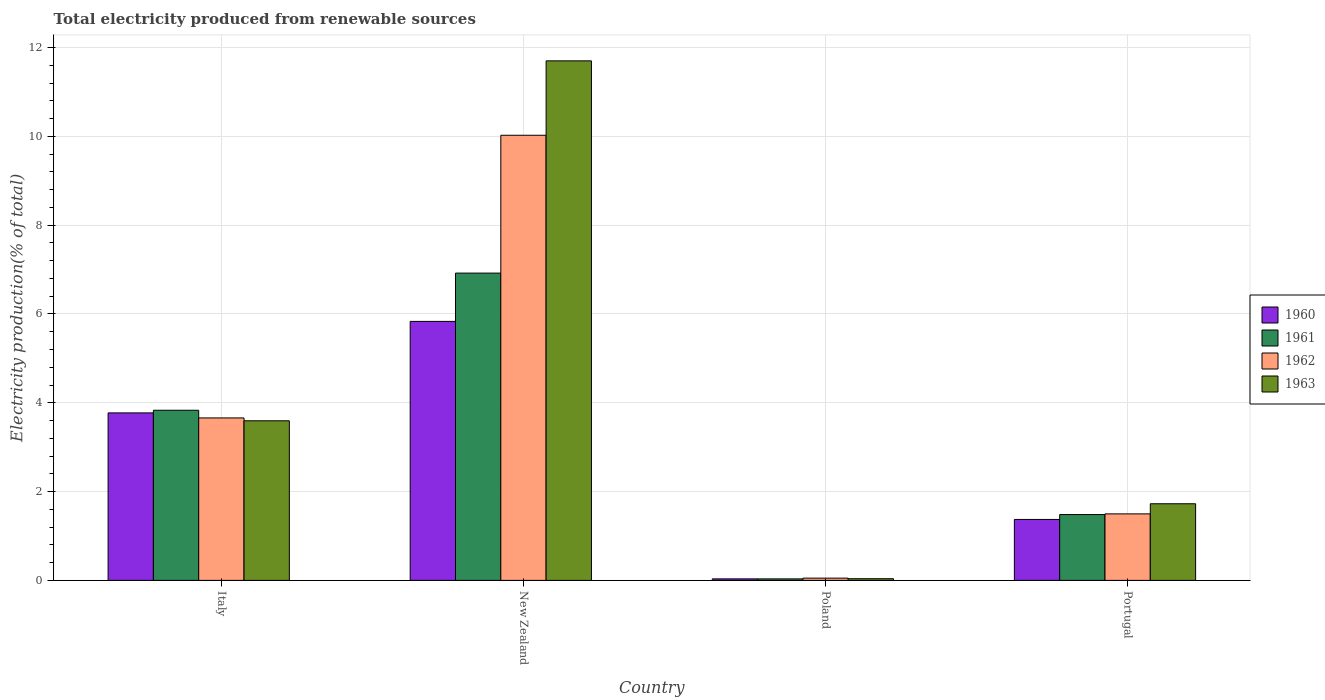Are the number of bars on each tick of the X-axis equal?
Your answer should be compact. Yes. What is the label of the 1st group of bars from the left?
Provide a short and direct response. Italy. What is the total electricity produced in 1963 in Italy?
Give a very brief answer. 3.59. Across all countries, what is the maximum total electricity produced in 1961?
Keep it short and to the point. 6.92. Across all countries, what is the minimum total electricity produced in 1960?
Ensure brevity in your answer.  0.03. In which country was the total electricity produced in 1962 maximum?
Offer a very short reply. New Zealand. In which country was the total electricity produced in 1960 minimum?
Provide a succinct answer. Poland. What is the total total electricity produced in 1963 in the graph?
Offer a terse response. 17.06. What is the difference between the total electricity produced in 1960 in Italy and that in New Zealand?
Your answer should be compact. -2.06. What is the difference between the total electricity produced in 1962 in Poland and the total electricity produced in 1961 in Portugal?
Your answer should be compact. -1.43. What is the average total electricity produced in 1963 per country?
Offer a terse response. 4.26. What is the difference between the total electricity produced of/in 1960 and total electricity produced of/in 1963 in Portugal?
Make the answer very short. -0.35. What is the ratio of the total electricity produced in 1960 in Italy to that in Portugal?
Your response must be concise. 2.75. Is the difference between the total electricity produced in 1960 in Italy and Portugal greater than the difference between the total electricity produced in 1963 in Italy and Portugal?
Make the answer very short. Yes. What is the difference between the highest and the second highest total electricity produced in 1960?
Make the answer very short. -2.4. What is the difference between the highest and the lowest total electricity produced in 1960?
Your response must be concise. 5.8. Is the sum of the total electricity produced in 1961 in Poland and Portugal greater than the maximum total electricity produced in 1960 across all countries?
Your response must be concise. No. What does the 4th bar from the right in New Zealand represents?
Keep it short and to the point. 1960. How many bars are there?
Make the answer very short. 16. Are all the bars in the graph horizontal?
Provide a succinct answer. No. What is the difference between two consecutive major ticks on the Y-axis?
Make the answer very short. 2. Are the values on the major ticks of Y-axis written in scientific E-notation?
Your response must be concise. No. Does the graph contain grids?
Provide a succinct answer. Yes. Where does the legend appear in the graph?
Provide a short and direct response. Center right. How are the legend labels stacked?
Make the answer very short. Vertical. What is the title of the graph?
Your response must be concise. Total electricity produced from renewable sources. What is the label or title of the X-axis?
Your response must be concise. Country. What is the Electricity production(% of total) in 1960 in Italy?
Make the answer very short. 3.77. What is the Electricity production(% of total) in 1961 in Italy?
Your response must be concise. 3.83. What is the Electricity production(% of total) of 1962 in Italy?
Your response must be concise. 3.66. What is the Electricity production(% of total) in 1963 in Italy?
Keep it short and to the point. 3.59. What is the Electricity production(% of total) of 1960 in New Zealand?
Offer a very short reply. 5.83. What is the Electricity production(% of total) in 1961 in New Zealand?
Give a very brief answer. 6.92. What is the Electricity production(% of total) in 1962 in New Zealand?
Provide a succinct answer. 10.02. What is the Electricity production(% of total) in 1963 in New Zealand?
Your answer should be very brief. 11.7. What is the Electricity production(% of total) in 1960 in Poland?
Keep it short and to the point. 0.03. What is the Electricity production(% of total) in 1961 in Poland?
Make the answer very short. 0.03. What is the Electricity production(% of total) in 1962 in Poland?
Your response must be concise. 0.05. What is the Electricity production(% of total) in 1963 in Poland?
Make the answer very short. 0.04. What is the Electricity production(% of total) of 1960 in Portugal?
Offer a terse response. 1.37. What is the Electricity production(% of total) of 1961 in Portugal?
Provide a succinct answer. 1.48. What is the Electricity production(% of total) in 1962 in Portugal?
Your response must be concise. 1.5. What is the Electricity production(% of total) in 1963 in Portugal?
Provide a succinct answer. 1.73. Across all countries, what is the maximum Electricity production(% of total) in 1960?
Ensure brevity in your answer.  5.83. Across all countries, what is the maximum Electricity production(% of total) of 1961?
Offer a very short reply. 6.92. Across all countries, what is the maximum Electricity production(% of total) of 1962?
Ensure brevity in your answer.  10.02. Across all countries, what is the maximum Electricity production(% of total) in 1963?
Offer a very short reply. 11.7. Across all countries, what is the minimum Electricity production(% of total) of 1960?
Provide a succinct answer. 0.03. Across all countries, what is the minimum Electricity production(% of total) in 1961?
Keep it short and to the point. 0.03. Across all countries, what is the minimum Electricity production(% of total) in 1962?
Offer a terse response. 0.05. Across all countries, what is the minimum Electricity production(% of total) in 1963?
Your answer should be very brief. 0.04. What is the total Electricity production(% of total) of 1960 in the graph?
Offer a very short reply. 11.01. What is the total Electricity production(% of total) in 1961 in the graph?
Ensure brevity in your answer.  12.27. What is the total Electricity production(% of total) in 1962 in the graph?
Your answer should be compact. 15.23. What is the total Electricity production(% of total) of 1963 in the graph?
Keep it short and to the point. 17.06. What is the difference between the Electricity production(% of total) of 1960 in Italy and that in New Zealand?
Provide a short and direct response. -2.06. What is the difference between the Electricity production(% of total) of 1961 in Italy and that in New Zealand?
Your response must be concise. -3.09. What is the difference between the Electricity production(% of total) in 1962 in Italy and that in New Zealand?
Give a very brief answer. -6.37. What is the difference between the Electricity production(% of total) of 1963 in Italy and that in New Zealand?
Your answer should be very brief. -8.11. What is the difference between the Electricity production(% of total) in 1960 in Italy and that in Poland?
Provide a short and direct response. 3.74. What is the difference between the Electricity production(% of total) of 1961 in Italy and that in Poland?
Offer a terse response. 3.8. What is the difference between the Electricity production(% of total) of 1962 in Italy and that in Poland?
Give a very brief answer. 3.61. What is the difference between the Electricity production(% of total) of 1963 in Italy and that in Poland?
Your response must be concise. 3.56. What is the difference between the Electricity production(% of total) in 1960 in Italy and that in Portugal?
Ensure brevity in your answer.  2.4. What is the difference between the Electricity production(% of total) in 1961 in Italy and that in Portugal?
Make the answer very short. 2.35. What is the difference between the Electricity production(% of total) of 1962 in Italy and that in Portugal?
Your response must be concise. 2.16. What is the difference between the Electricity production(% of total) in 1963 in Italy and that in Portugal?
Provide a short and direct response. 1.87. What is the difference between the Electricity production(% of total) of 1960 in New Zealand and that in Poland?
Provide a succinct answer. 5.8. What is the difference between the Electricity production(% of total) in 1961 in New Zealand and that in Poland?
Ensure brevity in your answer.  6.89. What is the difference between the Electricity production(% of total) of 1962 in New Zealand and that in Poland?
Your answer should be compact. 9.97. What is the difference between the Electricity production(% of total) in 1963 in New Zealand and that in Poland?
Provide a short and direct response. 11.66. What is the difference between the Electricity production(% of total) in 1960 in New Zealand and that in Portugal?
Provide a succinct answer. 4.46. What is the difference between the Electricity production(% of total) of 1961 in New Zealand and that in Portugal?
Your response must be concise. 5.44. What is the difference between the Electricity production(% of total) in 1962 in New Zealand and that in Portugal?
Offer a very short reply. 8.53. What is the difference between the Electricity production(% of total) in 1963 in New Zealand and that in Portugal?
Your answer should be compact. 9.97. What is the difference between the Electricity production(% of total) of 1960 in Poland and that in Portugal?
Your answer should be compact. -1.34. What is the difference between the Electricity production(% of total) in 1961 in Poland and that in Portugal?
Provide a short and direct response. -1.45. What is the difference between the Electricity production(% of total) of 1962 in Poland and that in Portugal?
Offer a terse response. -1.45. What is the difference between the Electricity production(% of total) in 1963 in Poland and that in Portugal?
Give a very brief answer. -1.69. What is the difference between the Electricity production(% of total) of 1960 in Italy and the Electricity production(% of total) of 1961 in New Zealand?
Offer a terse response. -3.15. What is the difference between the Electricity production(% of total) of 1960 in Italy and the Electricity production(% of total) of 1962 in New Zealand?
Offer a terse response. -6.25. What is the difference between the Electricity production(% of total) of 1960 in Italy and the Electricity production(% of total) of 1963 in New Zealand?
Make the answer very short. -7.93. What is the difference between the Electricity production(% of total) in 1961 in Italy and the Electricity production(% of total) in 1962 in New Zealand?
Keep it short and to the point. -6.19. What is the difference between the Electricity production(% of total) in 1961 in Italy and the Electricity production(% of total) in 1963 in New Zealand?
Give a very brief answer. -7.87. What is the difference between the Electricity production(% of total) in 1962 in Italy and the Electricity production(% of total) in 1963 in New Zealand?
Your answer should be compact. -8.04. What is the difference between the Electricity production(% of total) of 1960 in Italy and the Electricity production(% of total) of 1961 in Poland?
Provide a short and direct response. 3.74. What is the difference between the Electricity production(% of total) of 1960 in Italy and the Electricity production(% of total) of 1962 in Poland?
Give a very brief answer. 3.72. What is the difference between the Electricity production(% of total) in 1960 in Italy and the Electricity production(% of total) in 1963 in Poland?
Give a very brief answer. 3.73. What is the difference between the Electricity production(% of total) in 1961 in Italy and the Electricity production(% of total) in 1962 in Poland?
Give a very brief answer. 3.78. What is the difference between the Electricity production(% of total) in 1961 in Italy and the Electricity production(% of total) in 1963 in Poland?
Your answer should be compact. 3.79. What is the difference between the Electricity production(% of total) of 1962 in Italy and the Electricity production(% of total) of 1963 in Poland?
Give a very brief answer. 3.62. What is the difference between the Electricity production(% of total) in 1960 in Italy and the Electricity production(% of total) in 1961 in Portugal?
Keep it short and to the point. 2.29. What is the difference between the Electricity production(% of total) in 1960 in Italy and the Electricity production(% of total) in 1962 in Portugal?
Ensure brevity in your answer.  2.27. What is the difference between the Electricity production(% of total) in 1960 in Italy and the Electricity production(% of total) in 1963 in Portugal?
Give a very brief answer. 2.05. What is the difference between the Electricity production(% of total) of 1961 in Italy and the Electricity production(% of total) of 1962 in Portugal?
Keep it short and to the point. 2.33. What is the difference between the Electricity production(% of total) in 1961 in Italy and the Electricity production(% of total) in 1963 in Portugal?
Your answer should be compact. 2.11. What is the difference between the Electricity production(% of total) of 1962 in Italy and the Electricity production(% of total) of 1963 in Portugal?
Make the answer very short. 1.93. What is the difference between the Electricity production(% of total) of 1960 in New Zealand and the Electricity production(% of total) of 1961 in Poland?
Provide a short and direct response. 5.8. What is the difference between the Electricity production(% of total) in 1960 in New Zealand and the Electricity production(% of total) in 1962 in Poland?
Provide a succinct answer. 5.78. What is the difference between the Electricity production(% of total) in 1960 in New Zealand and the Electricity production(% of total) in 1963 in Poland?
Provide a short and direct response. 5.79. What is the difference between the Electricity production(% of total) of 1961 in New Zealand and the Electricity production(% of total) of 1962 in Poland?
Provide a short and direct response. 6.87. What is the difference between the Electricity production(% of total) of 1961 in New Zealand and the Electricity production(% of total) of 1963 in Poland?
Provide a succinct answer. 6.88. What is the difference between the Electricity production(% of total) in 1962 in New Zealand and the Electricity production(% of total) in 1963 in Poland?
Offer a terse response. 9.99. What is the difference between the Electricity production(% of total) in 1960 in New Zealand and the Electricity production(% of total) in 1961 in Portugal?
Offer a terse response. 4.35. What is the difference between the Electricity production(% of total) in 1960 in New Zealand and the Electricity production(% of total) in 1962 in Portugal?
Make the answer very short. 4.33. What is the difference between the Electricity production(% of total) in 1960 in New Zealand and the Electricity production(% of total) in 1963 in Portugal?
Offer a terse response. 4.11. What is the difference between the Electricity production(% of total) of 1961 in New Zealand and the Electricity production(% of total) of 1962 in Portugal?
Provide a short and direct response. 5.42. What is the difference between the Electricity production(% of total) in 1961 in New Zealand and the Electricity production(% of total) in 1963 in Portugal?
Your answer should be compact. 5.19. What is the difference between the Electricity production(% of total) in 1962 in New Zealand and the Electricity production(% of total) in 1963 in Portugal?
Offer a terse response. 8.3. What is the difference between the Electricity production(% of total) of 1960 in Poland and the Electricity production(% of total) of 1961 in Portugal?
Offer a very short reply. -1.45. What is the difference between the Electricity production(% of total) in 1960 in Poland and the Electricity production(% of total) in 1962 in Portugal?
Provide a succinct answer. -1.46. What is the difference between the Electricity production(% of total) of 1960 in Poland and the Electricity production(% of total) of 1963 in Portugal?
Provide a short and direct response. -1.69. What is the difference between the Electricity production(% of total) in 1961 in Poland and the Electricity production(% of total) in 1962 in Portugal?
Your answer should be compact. -1.46. What is the difference between the Electricity production(% of total) in 1961 in Poland and the Electricity production(% of total) in 1963 in Portugal?
Give a very brief answer. -1.69. What is the difference between the Electricity production(% of total) of 1962 in Poland and the Electricity production(% of total) of 1963 in Portugal?
Make the answer very short. -1.67. What is the average Electricity production(% of total) in 1960 per country?
Give a very brief answer. 2.75. What is the average Electricity production(% of total) of 1961 per country?
Make the answer very short. 3.07. What is the average Electricity production(% of total) of 1962 per country?
Make the answer very short. 3.81. What is the average Electricity production(% of total) of 1963 per country?
Keep it short and to the point. 4.26. What is the difference between the Electricity production(% of total) of 1960 and Electricity production(% of total) of 1961 in Italy?
Offer a terse response. -0.06. What is the difference between the Electricity production(% of total) of 1960 and Electricity production(% of total) of 1962 in Italy?
Provide a succinct answer. 0.11. What is the difference between the Electricity production(% of total) of 1960 and Electricity production(% of total) of 1963 in Italy?
Ensure brevity in your answer.  0.18. What is the difference between the Electricity production(% of total) of 1961 and Electricity production(% of total) of 1962 in Italy?
Make the answer very short. 0.17. What is the difference between the Electricity production(% of total) in 1961 and Electricity production(% of total) in 1963 in Italy?
Provide a succinct answer. 0.24. What is the difference between the Electricity production(% of total) of 1962 and Electricity production(% of total) of 1963 in Italy?
Keep it short and to the point. 0.06. What is the difference between the Electricity production(% of total) of 1960 and Electricity production(% of total) of 1961 in New Zealand?
Your answer should be very brief. -1.09. What is the difference between the Electricity production(% of total) in 1960 and Electricity production(% of total) in 1962 in New Zealand?
Make the answer very short. -4.19. What is the difference between the Electricity production(% of total) of 1960 and Electricity production(% of total) of 1963 in New Zealand?
Provide a short and direct response. -5.87. What is the difference between the Electricity production(% of total) of 1961 and Electricity production(% of total) of 1962 in New Zealand?
Your response must be concise. -3.1. What is the difference between the Electricity production(% of total) in 1961 and Electricity production(% of total) in 1963 in New Zealand?
Offer a very short reply. -4.78. What is the difference between the Electricity production(% of total) in 1962 and Electricity production(% of total) in 1963 in New Zealand?
Provide a short and direct response. -1.68. What is the difference between the Electricity production(% of total) in 1960 and Electricity production(% of total) in 1962 in Poland?
Offer a very short reply. -0.02. What is the difference between the Electricity production(% of total) in 1960 and Electricity production(% of total) in 1963 in Poland?
Give a very brief answer. -0. What is the difference between the Electricity production(% of total) of 1961 and Electricity production(% of total) of 1962 in Poland?
Offer a very short reply. -0.02. What is the difference between the Electricity production(% of total) of 1961 and Electricity production(% of total) of 1963 in Poland?
Your response must be concise. -0. What is the difference between the Electricity production(% of total) of 1962 and Electricity production(% of total) of 1963 in Poland?
Provide a short and direct response. 0.01. What is the difference between the Electricity production(% of total) of 1960 and Electricity production(% of total) of 1961 in Portugal?
Provide a short and direct response. -0.11. What is the difference between the Electricity production(% of total) in 1960 and Electricity production(% of total) in 1962 in Portugal?
Provide a succinct answer. -0.13. What is the difference between the Electricity production(% of total) of 1960 and Electricity production(% of total) of 1963 in Portugal?
Offer a terse response. -0.35. What is the difference between the Electricity production(% of total) in 1961 and Electricity production(% of total) in 1962 in Portugal?
Give a very brief answer. -0.02. What is the difference between the Electricity production(% of total) of 1961 and Electricity production(% of total) of 1963 in Portugal?
Give a very brief answer. -0.24. What is the difference between the Electricity production(% of total) in 1962 and Electricity production(% of total) in 1963 in Portugal?
Your response must be concise. -0.23. What is the ratio of the Electricity production(% of total) in 1960 in Italy to that in New Zealand?
Make the answer very short. 0.65. What is the ratio of the Electricity production(% of total) in 1961 in Italy to that in New Zealand?
Provide a short and direct response. 0.55. What is the ratio of the Electricity production(% of total) of 1962 in Italy to that in New Zealand?
Provide a succinct answer. 0.36. What is the ratio of the Electricity production(% of total) in 1963 in Italy to that in New Zealand?
Ensure brevity in your answer.  0.31. What is the ratio of the Electricity production(% of total) of 1960 in Italy to that in Poland?
Your response must be concise. 110.45. What is the ratio of the Electricity production(% of total) of 1961 in Italy to that in Poland?
Your response must be concise. 112.3. What is the ratio of the Electricity production(% of total) of 1962 in Italy to that in Poland?
Keep it short and to the point. 71.88. What is the ratio of the Electricity production(% of total) in 1963 in Italy to that in Poland?
Give a very brief answer. 94.84. What is the ratio of the Electricity production(% of total) of 1960 in Italy to that in Portugal?
Your answer should be compact. 2.75. What is the ratio of the Electricity production(% of total) of 1961 in Italy to that in Portugal?
Ensure brevity in your answer.  2.58. What is the ratio of the Electricity production(% of total) of 1962 in Italy to that in Portugal?
Give a very brief answer. 2.44. What is the ratio of the Electricity production(% of total) of 1963 in Italy to that in Portugal?
Give a very brief answer. 2.08. What is the ratio of the Electricity production(% of total) in 1960 in New Zealand to that in Poland?
Provide a short and direct response. 170.79. What is the ratio of the Electricity production(% of total) in 1961 in New Zealand to that in Poland?
Make the answer very short. 202.83. What is the ratio of the Electricity production(% of total) of 1962 in New Zealand to that in Poland?
Provide a short and direct response. 196.95. What is the ratio of the Electricity production(% of total) in 1963 in New Zealand to that in Poland?
Ensure brevity in your answer.  308.73. What is the ratio of the Electricity production(% of total) of 1960 in New Zealand to that in Portugal?
Keep it short and to the point. 4.25. What is the ratio of the Electricity production(% of total) of 1961 in New Zealand to that in Portugal?
Ensure brevity in your answer.  4.67. What is the ratio of the Electricity production(% of total) in 1962 in New Zealand to that in Portugal?
Your answer should be very brief. 6.69. What is the ratio of the Electricity production(% of total) of 1963 in New Zealand to that in Portugal?
Offer a terse response. 6.78. What is the ratio of the Electricity production(% of total) of 1960 in Poland to that in Portugal?
Offer a very short reply. 0.02. What is the ratio of the Electricity production(% of total) in 1961 in Poland to that in Portugal?
Give a very brief answer. 0.02. What is the ratio of the Electricity production(% of total) of 1962 in Poland to that in Portugal?
Your response must be concise. 0.03. What is the ratio of the Electricity production(% of total) of 1963 in Poland to that in Portugal?
Your response must be concise. 0.02. What is the difference between the highest and the second highest Electricity production(% of total) of 1960?
Offer a very short reply. 2.06. What is the difference between the highest and the second highest Electricity production(% of total) in 1961?
Your answer should be very brief. 3.09. What is the difference between the highest and the second highest Electricity production(% of total) of 1962?
Ensure brevity in your answer.  6.37. What is the difference between the highest and the second highest Electricity production(% of total) of 1963?
Provide a succinct answer. 8.11. What is the difference between the highest and the lowest Electricity production(% of total) in 1960?
Ensure brevity in your answer.  5.8. What is the difference between the highest and the lowest Electricity production(% of total) of 1961?
Provide a succinct answer. 6.89. What is the difference between the highest and the lowest Electricity production(% of total) in 1962?
Your answer should be very brief. 9.97. What is the difference between the highest and the lowest Electricity production(% of total) of 1963?
Keep it short and to the point. 11.66. 